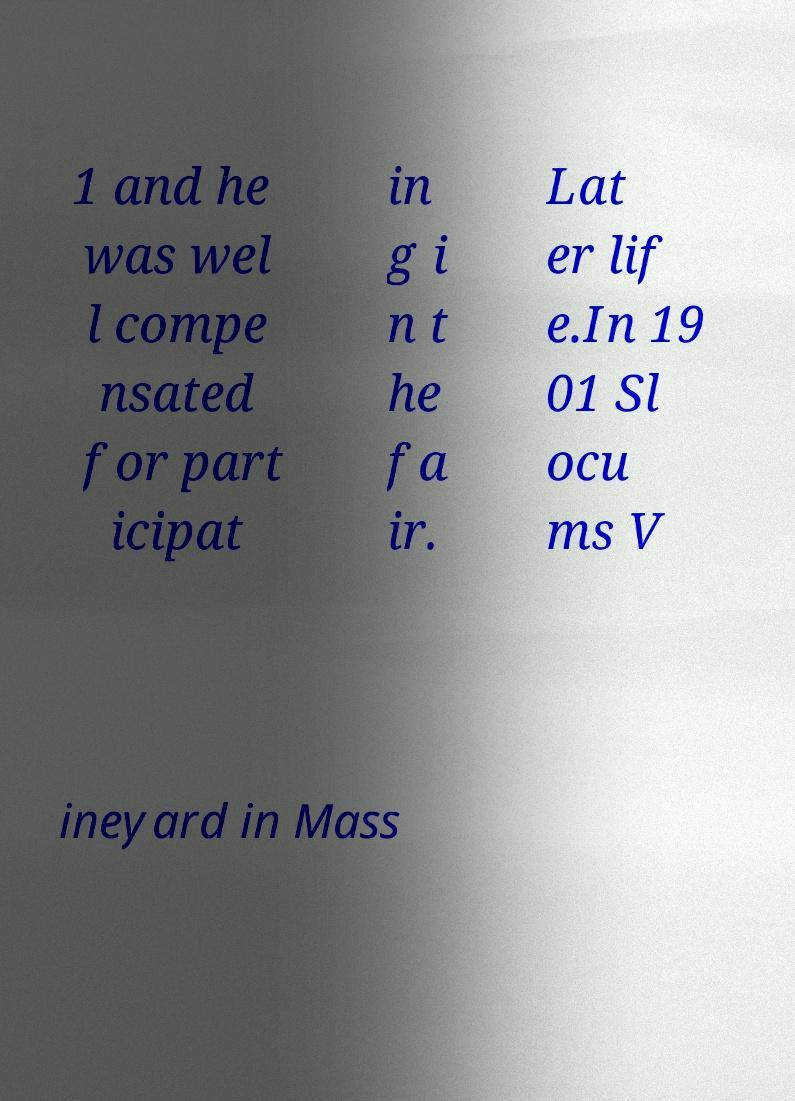Can you accurately transcribe the text from the provided image for me? 1 and he was wel l compe nsated for part icipat in g i n t he fa ir. Lat er lif e.In 19 01 Sl ocu ms V ineyard in Mass 